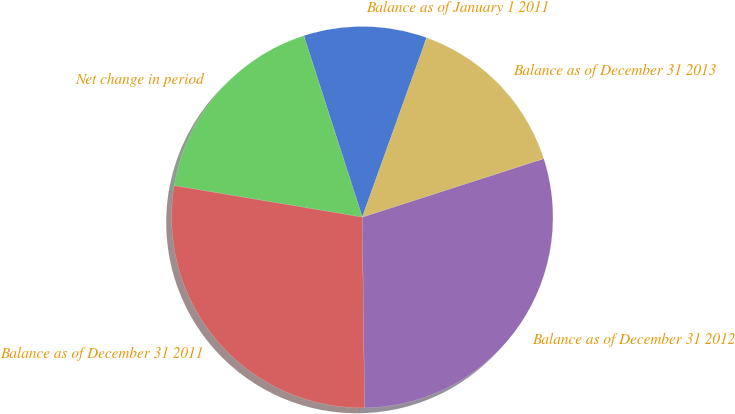Convert chart. <chart><loc_0><loc_0><loc_500><loc_500><pie_chart><fcel>Balance as of January 1 2011<fcel>Net change in period<fcel>Balance as of December 31 2011<fcel>Balance as of December 31 2012<fcel>Balance as of December 31 2013<nl><fcel>10.45%<fcel>17.39%<fcel>27.84%<fcel>29.77%<fcel>14.55%<nl></chart> 